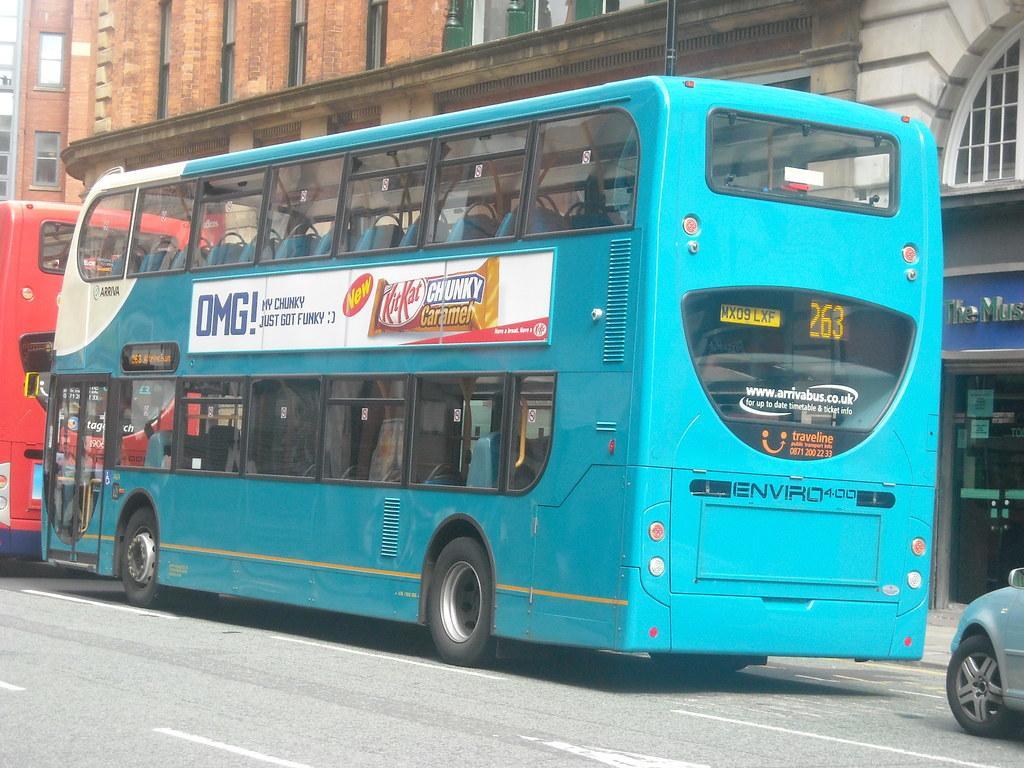In one or two sentences, can you explain what this image depicts? In this picture there are buses and there is a car on the road. At the back there are buildings and there is a pole. On the right side of the image there is a door and there is a text on the wall. At the bottom there is a road. 